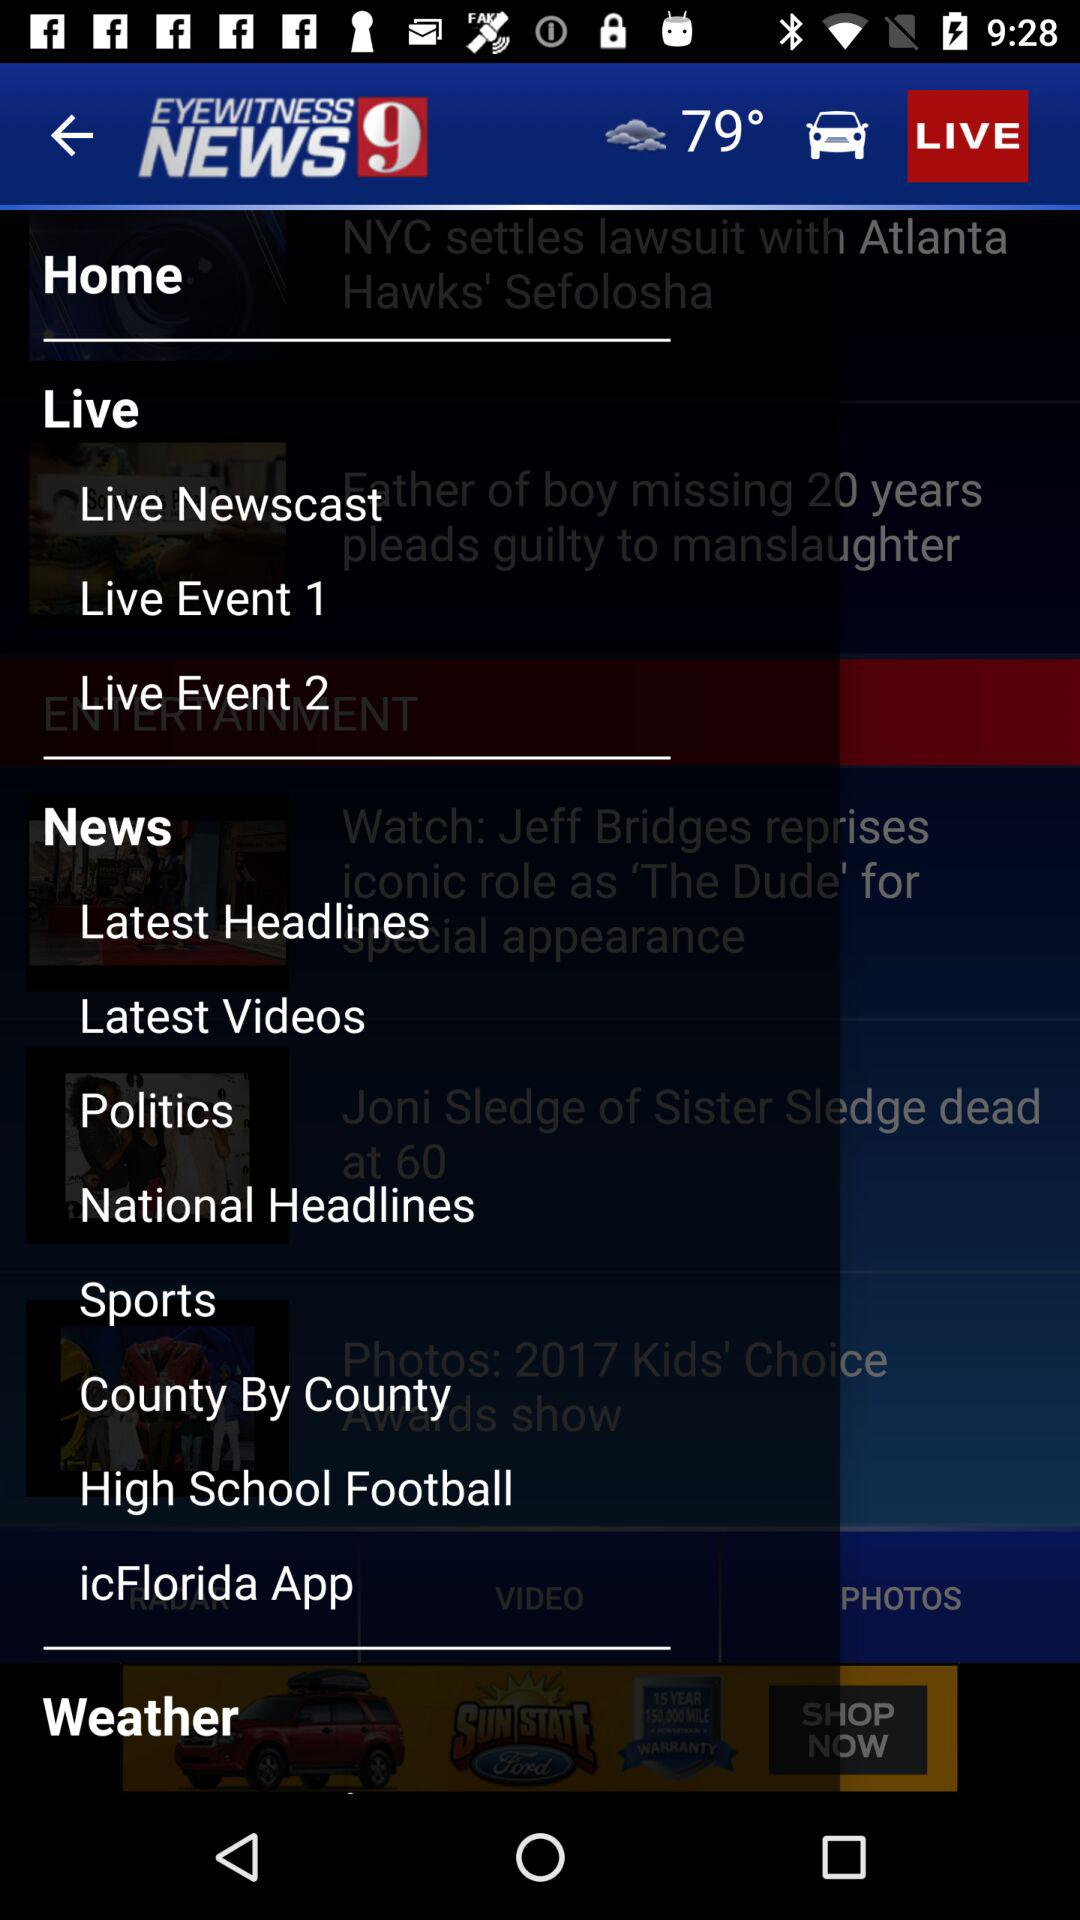What is the temperature? The temperature is 79°. 